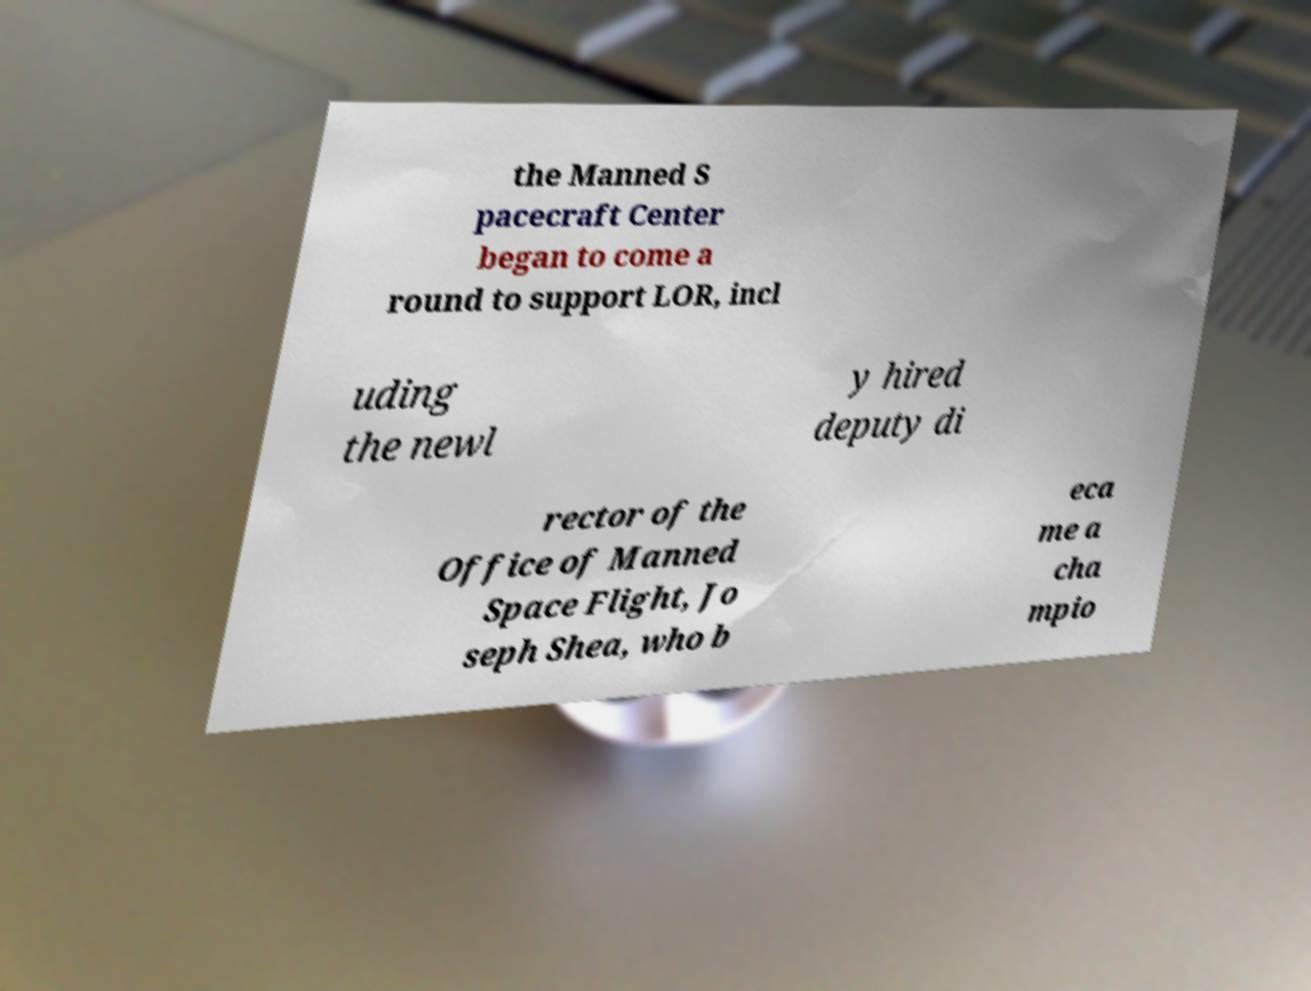Can you read and provide the text displayed in the image?This photo seems to have some interesting text. Can you extract and type it out for me? the Manned S pacecraft Center began to come a round to support LOR, incl uding the newl y hired deputy di rector of the Office of Manned Space Flight, Jo seph Shea, who b eca me a cha mpio 